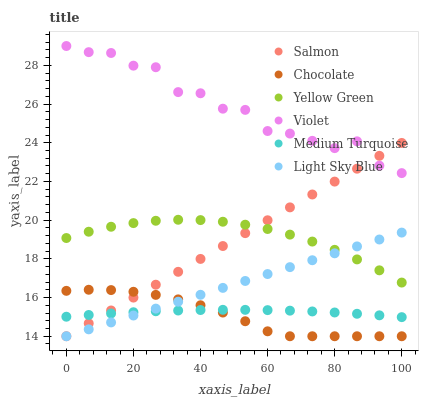Does Chocolate have the minimum area under the curve?
Answer yes or no. Yes. Does Violet have the maximum area under the curve?
Answer yes or no. Yes. Does Salmon have the minimum area under the curve?
Answer yes or no. No. Does Salmon have the maximum area under the curve?
Answer yes or no. No. Is Light Sky Blue the smoothest?
Answer yes or no. Yes. Is Violet the roughest?
Answer yes or no. Yes. Is Salmon the smoothest?
Answer yes or no. No. Is Salmon the roughest?
Answer yes or no. No. Does Salmon have the lowest value?
Answer yes or no. Yes. Does Medium Turquoise have the lowest value?
Answer yes or no. No. Does Violet have the highest value?
Answer yes or no. Yes. Does Salmon have the highest value?
Answer yes or no. No. Is Chocolate less than Violet?
Answer yes or no. Yes. Is Violet greater than Medium Turquoise?
Answer yes or no. Yes. Does Salmon intersect Yellow Green?
Answer yes or no. Yes. Is Salmon less than Yellow Green?
Answer yes or no. No. Is Salmon greater than Yellow Green?
Answer yes or no. No. Does Chocolate intersect Violet?
Answer yes or no. No. 